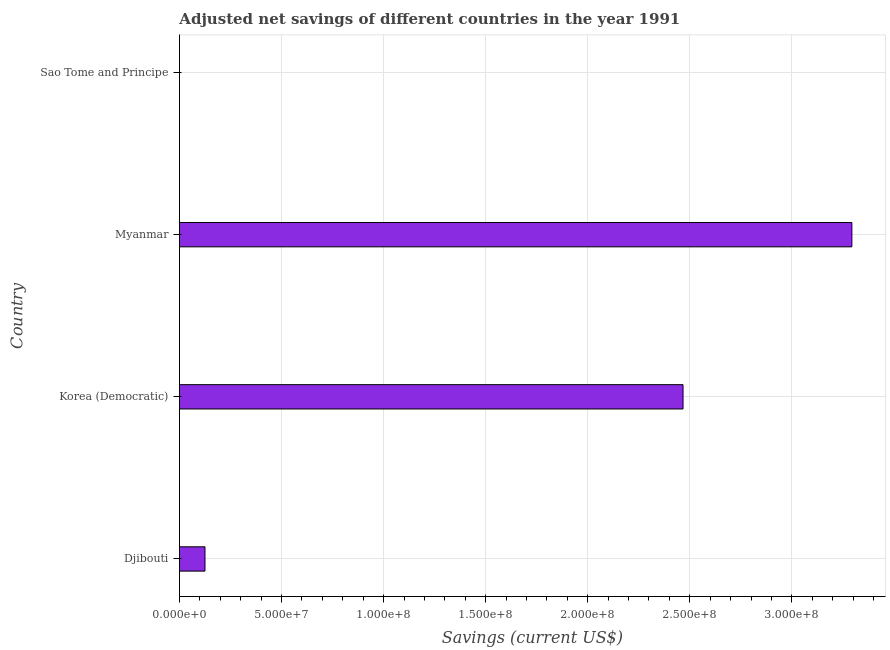Does the graph contain grids?
Provide a short and direct response. Yes. What is the title of the graph?
Offer a terse response. Adjusted net savings of different countries in the year 1991. What is the label or title of the X-axis?
Keep it short and to the point. Savings (current US$). What is the label or title of the Y-axis?
Ensure brevity in your answer.  Country. What is the adjusted net savings in Korea (Democratic)?
Ensure brevity in your answer.  2.47e+08. Across all countries, what is the maximum adjusted net savings?
Your answer should be very brief. 3.29e+08. Across all countries, what is the minimum adjusted net savings?
Your response must be concise. 2586.14. In which country was the adjusted net savings maximum?
Make the answer very short. Myanmar. In which country was the adjusted net savings minimum?
Ensure brevity in your answer.  Sao Tome and Principe. What is the sum of the adjusted net savings?
Offer a very short reply. 5.89e+08. What is the difference between the adjusted net savings in Korea (Democratic) and Myanmar?
Your answer should be compact. -8.27e+07. What is the average adjusted net savings per country?
Offer a very short reply. 1.47e+08. What is the median adjusted net savings?
Provide a short and direct response. 1.30e+08. In how many countries, is the adjusted net savings greater than 260000000 US$?
Give a very brief answer. 1. What is the ratio of the adjusted net savings in Korea (Democratic) to that in Myanmar?
Make the answer very short. 0.75. Is the adjusted net savings in Korea (Democratic) less than that in Sao Tome and Principe?
Keep it short and to the point. No. What is the difference between the highest and the second highest adjusted net savings?
Provide a succinct answer. 8.27e+07. What is the difference between the highest and the lowest adjusted net savings?
Provide a short and direct response. 3.29e+08. How many bars are there?
Provide a short and direct response. 4. Are all the bars in the graph horizontal?
Make the answer very short. Yes. What is the Savings (current US$) of Djibouti?
Provide a succinct answer. 1.25e+07. What is the Savings (current US$) of Korea (Democratic)?
Offer a terse response. 2.47e+08. What is the Savings (current US$) in Myanmar?
Your answer should be compact. 3.29e+08. What is the Savings (current US$) of Sao Tome and Principe?
Provide a short and direct response. 2586.14. What is the difference between the Savings (current US$) in Djibouti and Korea (Democratic)?
Offer a terse response. -2.34e+08. What is the difference between the Savings (current US$) in Djibouti and Myanmar?
Make the answer very short. -3.17e+08. What is the difference between the Savings (current US$) in Djibouti and Sao Tome and Principe?
Keep it short and to the point. 1.25e+07. What is the difference between the Savings (current US$) in Korea (Democratic) and Myanmar?
Your response must be concise. -8.27e+07. What is the difference between the Savings (current US$) in Korea (Democratic) and Sao Tome and Principe?
Offer a terse response. 2.47e+08. What is the difference between the Savings (current US$) in Myanmar and Sao Tome and Principe?
Offer a terse response. 3.29e+08. What is the ratio of the Savings (current US$) in Djibouti to that in Korea (Democratic)?
Your answer should be very brief. 0.05. What is the ratio of the Savings (current US$) in Djibouti to that in Myanmar?
Offer a terse response. 0.04. What is the ratio of the Savings (current US$) in Djibouti to that in Sao Tome and Principe?
Offer a very short reply. 4843.78. What is the ratio of the Savings (current US$) in Korea (Democratic) to that in Myanmar?
Provide a short and direct response. 0.75. What is the ratio of the Savings (current US$) in Korea (Democratic) to that in Sao Tome and Principe?
Your answer should be very brief. 9.54e+04. What is the ratio of the Savings (current US$) in Myanmar to that in Sao Tome and Principe?
Give a very brief answer. 1.27e+05. 